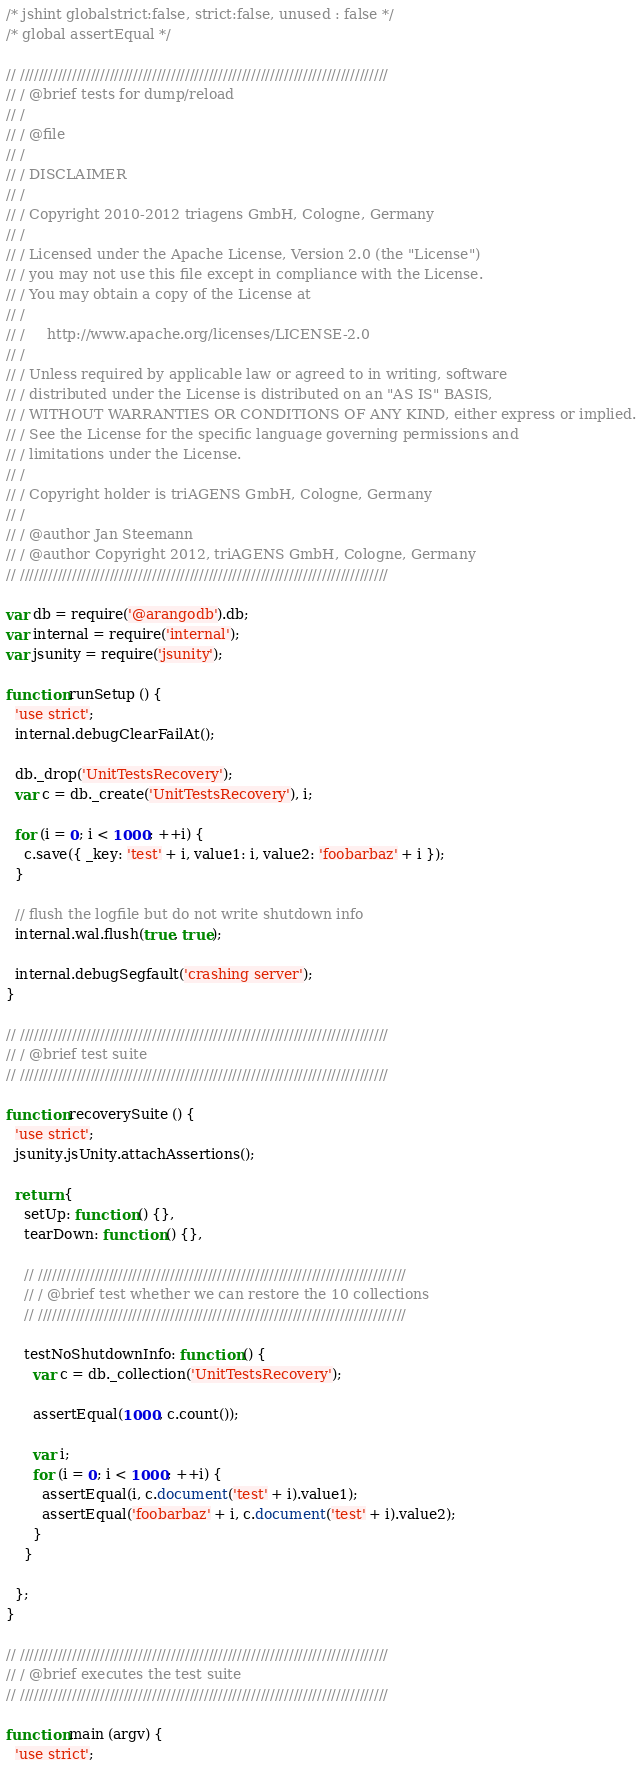Convert code to text. <code><loc_0><loc_0><loc_500><loc_500><_JavaScript_>/* jshint globalstrict:false, strict:false, unused : false */
/* global assertEqual */

// //////////////////////////////////////////////////////////////////////////////
// / @brief tests for dump/reload
// /
// / @file
// /
// / DISCLAIMER
// /
// / Copyright 2010-2012 triagens GmbH, Cologne, Germany
// /
// / Licensed under the Apache License, Version 2.0 (the "License")
// / you may not use this file except in compliance with the License.
// / You may obtain a copy of the License at
// /
// /     http://www.apache.org/licenses/LICENSE-2.0
// /
// / Unless required by applicable law or agreed to in writing, software
// / distributed under the License is distributed on an "AS IS" BASIS,
// / WITHOUT WARRANTIES OR CONDITIONS OF ANY KIND, either express or implied.
// / See the License for the specific language governing permissions and
// / limitations under the License.
// /
// / Copyright holder is triAGENS GmbH, Cologne, Germany
// /
// / @author Jan Steemann
// / @author Copyright 2012, triAGENS GmbH, Cologne, Germany
// //////////////////////////////////////////////////////////////////////////////

var db = require('@arangodb').db;
var internal = require('internal');
var jsunity = require('jsunity');

function runSetup () {
  'use strict';
  internal.debugClearFailAt();

  db._drop('UnitTestsRecovery');
  var c = db._create('UnitTestsRecovery'), i;

  for (i = 0; i < 1000; ++i) {
    c.save({ _key: 'test' + i, value1: i, value2: 'foobarbaz' + i });
  }

  // flush the logfile but do not write shutdown info
  internal.wal.flush(true, true);

  internal.debugSegfault('crashing server');
}

// //////////////////////////////////////////////////////////////////////////////
// / @brief test suite
// //////////////////////////////////////////////////////////////////////////////

function recoverySuite () {
  'use strict';
  jsunity.jsUnity.attachAssertions();

  return {
    setUp: function () {},
    tearDown: function () {},

    // //////////////////////////////////////////////////////////////////////////////
    // / @brief test whether we can restore the 10 collections
    // //////////////////////////////////////////////////////////////////////////////

    testNoShutdownInfo: function () {
      var c = db._collection('UnitTestsRecovery');

      assertEqual(1000, c.count());

      var i;
      for (i = 0; i < 1000; ++i) {
        assertEqual(i, c.document('test' + i).value1);
        assertEqual('foobarbaz' + i, c.document('test' + i).value2);
      }
    }

  };
}

// //////////////////////////////////////////////////////////////////////////////
// / @brief executes the test suite
// //////////////////////////////////////////////////////////////////////////////

function main (argv) {
  'use strict';</code> 